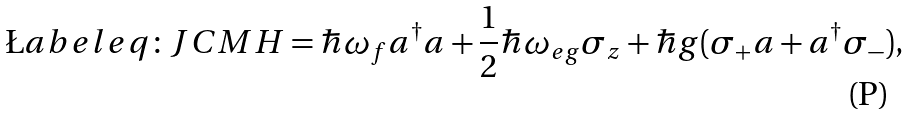Convert formula to latex. <formula><loc_0><loc_0><loc_500><loc_500>\L a b e l { e q \colon J C M } H = \hbar { \omega } _ { f } a ^ { \dagger } a + \frac { 1 } { 2 } \hbar { \omega } _ { e g } \sigma _ { z } + \hbar { g } ( \sigma _ { + } a + a ^ { \dagger } \sigma _ { - } ) ,</formula> 